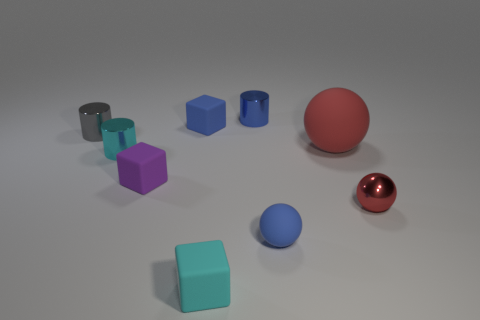Add 1 brown shiny blocks. How many objects exist? 10 Subtract all cylinders. How many objects are left? 6 Add 1 small cubes. How many small cubes are left? 4 Add 1 cyan shiny cubes. How many cyan shiny cubes exist? 1 Subtract 1 purple blocks. How many objects are left? 8 Subtract all tiny cyan cylinders. Subtract all brown matte cylinders. How many objects are left? 8 